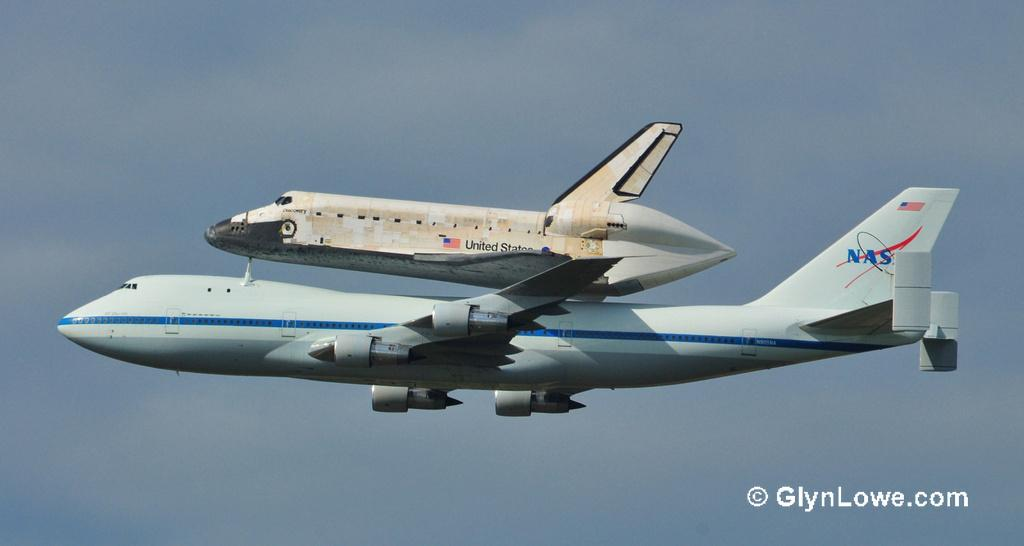<image>
Share a concise interpretation of the image provided. A large nasa airplane with a space shuttle perched on top of it. 